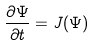<formula> <loc_0><loc_0><loc_500><loc_500>\frac { \partial \Psi } { \partial t } = J ( \Psi )</formula> 